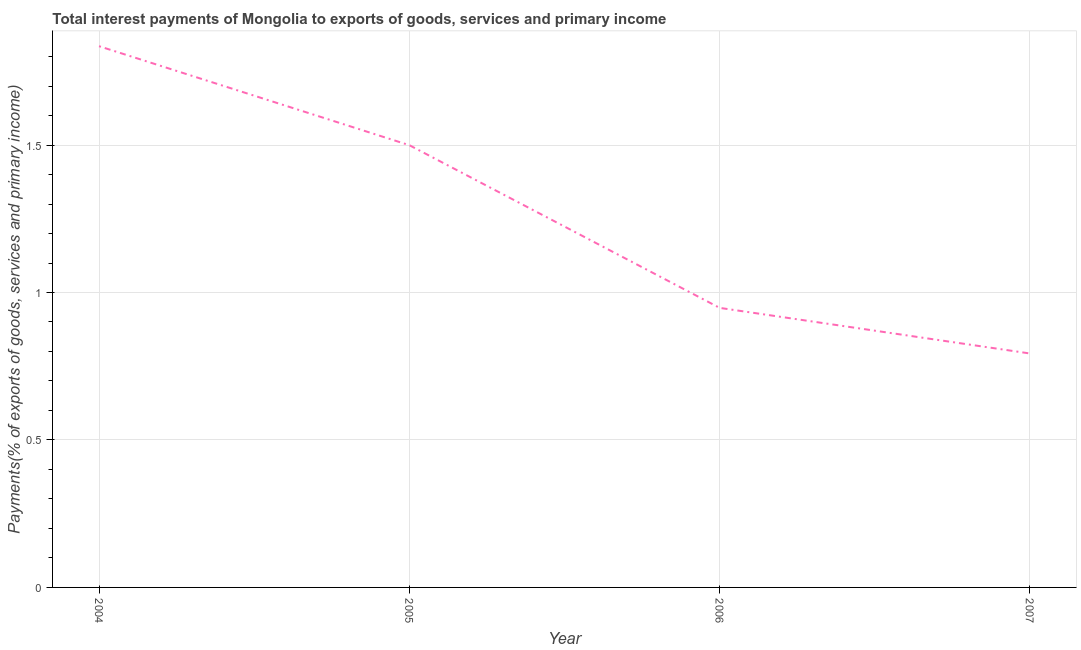What is the total interest payments on external debt in 2005?
Keep it short and to the point. 1.5. Across all years, what is the maximum total interest payments on external debt?
Offer a very short reply. 1.84. Across all years, what is the minimum total interest payments on external debt?
Offer a very short reply. 0.79. In which year was the total interest payments on external debt minimum?
Offer a terse response. 2007. What is the sum of the total interest payments on external debt?
Offer a terse response. 5.08. What is the difference between the total interest payments on external debt in 2004 and 2006?
Your answer should be very brief. 0.89. What is the average total interest payments on external debt per year?
Your response must be concise. 1.27. What is the median total interest payments on external debt?
Give a very brief answer. 1.22. Do a majority of the years between 2004 and 2005 (inclusive) have total interest payments on external debt greater than 1.4 %?
Ensure brevity in your answer.  Yes. What is the ratio of the total interest payments on external debt in 2004 to that in 2005?
Give a very brief answer. 1.22. Is the total interest payments on external debt in 2005 less than that in 2006?
Keep it short and to the point. No. What is the difference between the highest and the second highest total interest payments on external debt?
Keep it short and to the point. 0.34. What is the difference between the highest and the lowest total interest payments on external debt?
Your answer should be compact. 1.04. In how many years, is the total interest payments on external debt greater than the average total interest payments on external debt taken over all years?
Ensure brevity in your answer.  2. Does the total interest payments on external debt monotonically increase over the years?
Offer a very short reply. No. How many lines are there?
Make the answer very short. 1. How many years are there in the graph?
Your answer should be very brief. 4. Are the values on the major ticks of Y-axis written in scientific E-notation?
Give a very brief answer. No. What is the title of the graph?
Your answer should be very brief. Total interest payments of Mongolia to exports of goods, services and primary income. What is the label or title of the X-axis?
Your answer should be compact. Year. What is the label or title of the Y-axis?
Make the answer very short. Payments(% of exports of goods, services and primary income). What is the Payments(% of exports of goods, services and primary income) in 2004?
Offer a terse response. 1.84. What is the Payments(% of exports of goods, services and primary income) in 2005?
Your answer should be compact. 1.5. What is the Payments(% of exports of goods, services and primary income) in 2006?
Your answer should be compact. 0.95. What is the Payments(% of exports of goods, services and primary income) in 2007?
Your response must be concise. 0.79. What is the difference between the Payments(% of exports of goods, services and primary income) in 2004 and 2005?
Provide a short and direct response. 0.34. What is the difference between the Payments(% of exports of goods, services and primary income) in 2004 and 2006?
Offer a terse response. 0.89. What is the difference between the Payments(% of exports of goods, services and primary income) in 2004 and 2007?
Ensure brevity in your answer.  1.04. What is the difference between the Payments(% of exports of goods, services and primary income) in 2005 and 2006?
Your answer should be compact. 0.55. What is the difference between the Payments(% of exports of goods, services and primary income) in 2005 and 2007?
Keep it short and to the point. 0.71. What is the difference between the Payments(% of exports of goods, services and primary income) in 2006 and 2007?
Provide a short and direct response. 0.15. What is the ratio of the Payments(% of exports of goods, services and primary income) in 2004 to that in 2005?
Give a very brief answer. 1.22. What is the ratio of the Payments(% of exports of goods, services and primary income) in 2004 to that in 2006?
Give a very brief answer. 1.94. What is the ratio of the Payments(% of exports of goods, services and primary income) in 2004 to that in 2007?
Your answer should be very brief. 2.31. What is the ratio of the Payments(% of exports of goods, services and primary income) in 2005 to that in 2006?
Your answer should be compact. 1.58. What is the ratio of the Payments(% of exports of goods, services and primary income) in 2005 to that in 2007?
Your answer should be compact. 1.89. What is the ratio of the Payments(% of exports of goods, services and primary income) in 2006 to that in 2007?
Offer a terse response. 1.2. 